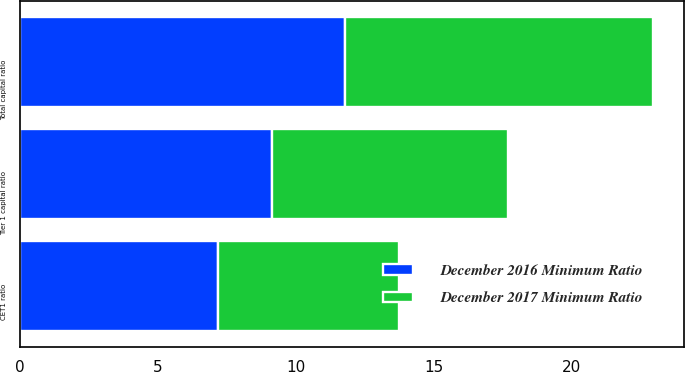Convert chart to OTSL. <chart><loc_0><loc_0><loc_500><loc_500><stacked_bar_chart><ecel><fcel>CET1 ratio<fcel>Tier 1 capital ratio<fcel>Total capital ratio<nl><fcel>December 2016 Minimum Ratio<fcel>7.17<fcel>9.14<fcel>11.77<nl><fcel>December 2017 Minimum Ratio<fcel>6.55<fcel>8.53<fcel>11.16<nl></chart> 